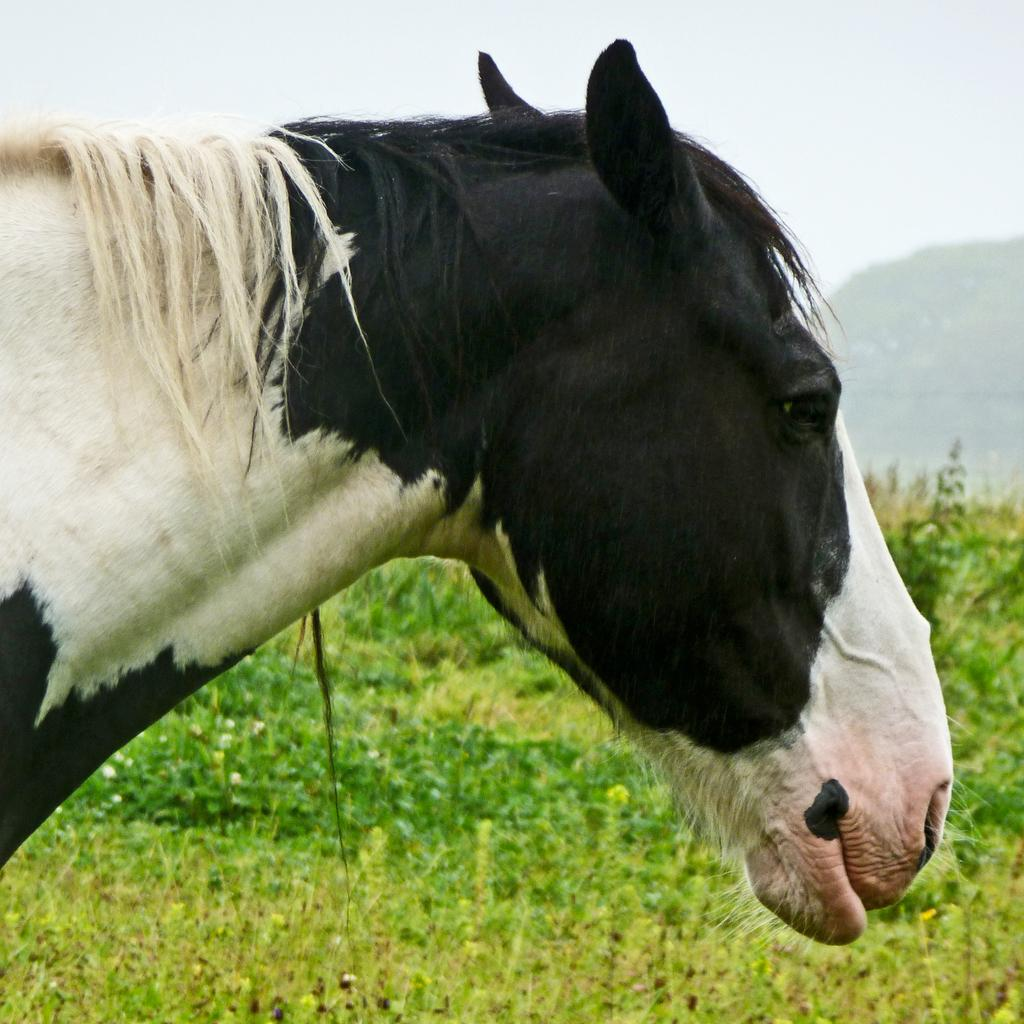What type of animal is in the image? There is a black and white horse in the image. What can be seen behind the horse? There are small plants behind the horse. What is the color of the plants? The plants are green in color. What is visible in the background of the image? There is a hill and the sky visible in the background of the image. Where can the toothpaste be found in the image? There is no toothpaste present in the image. What type of snack is being served in the image? The image does not depict any food or snacks, such as popcorn. 